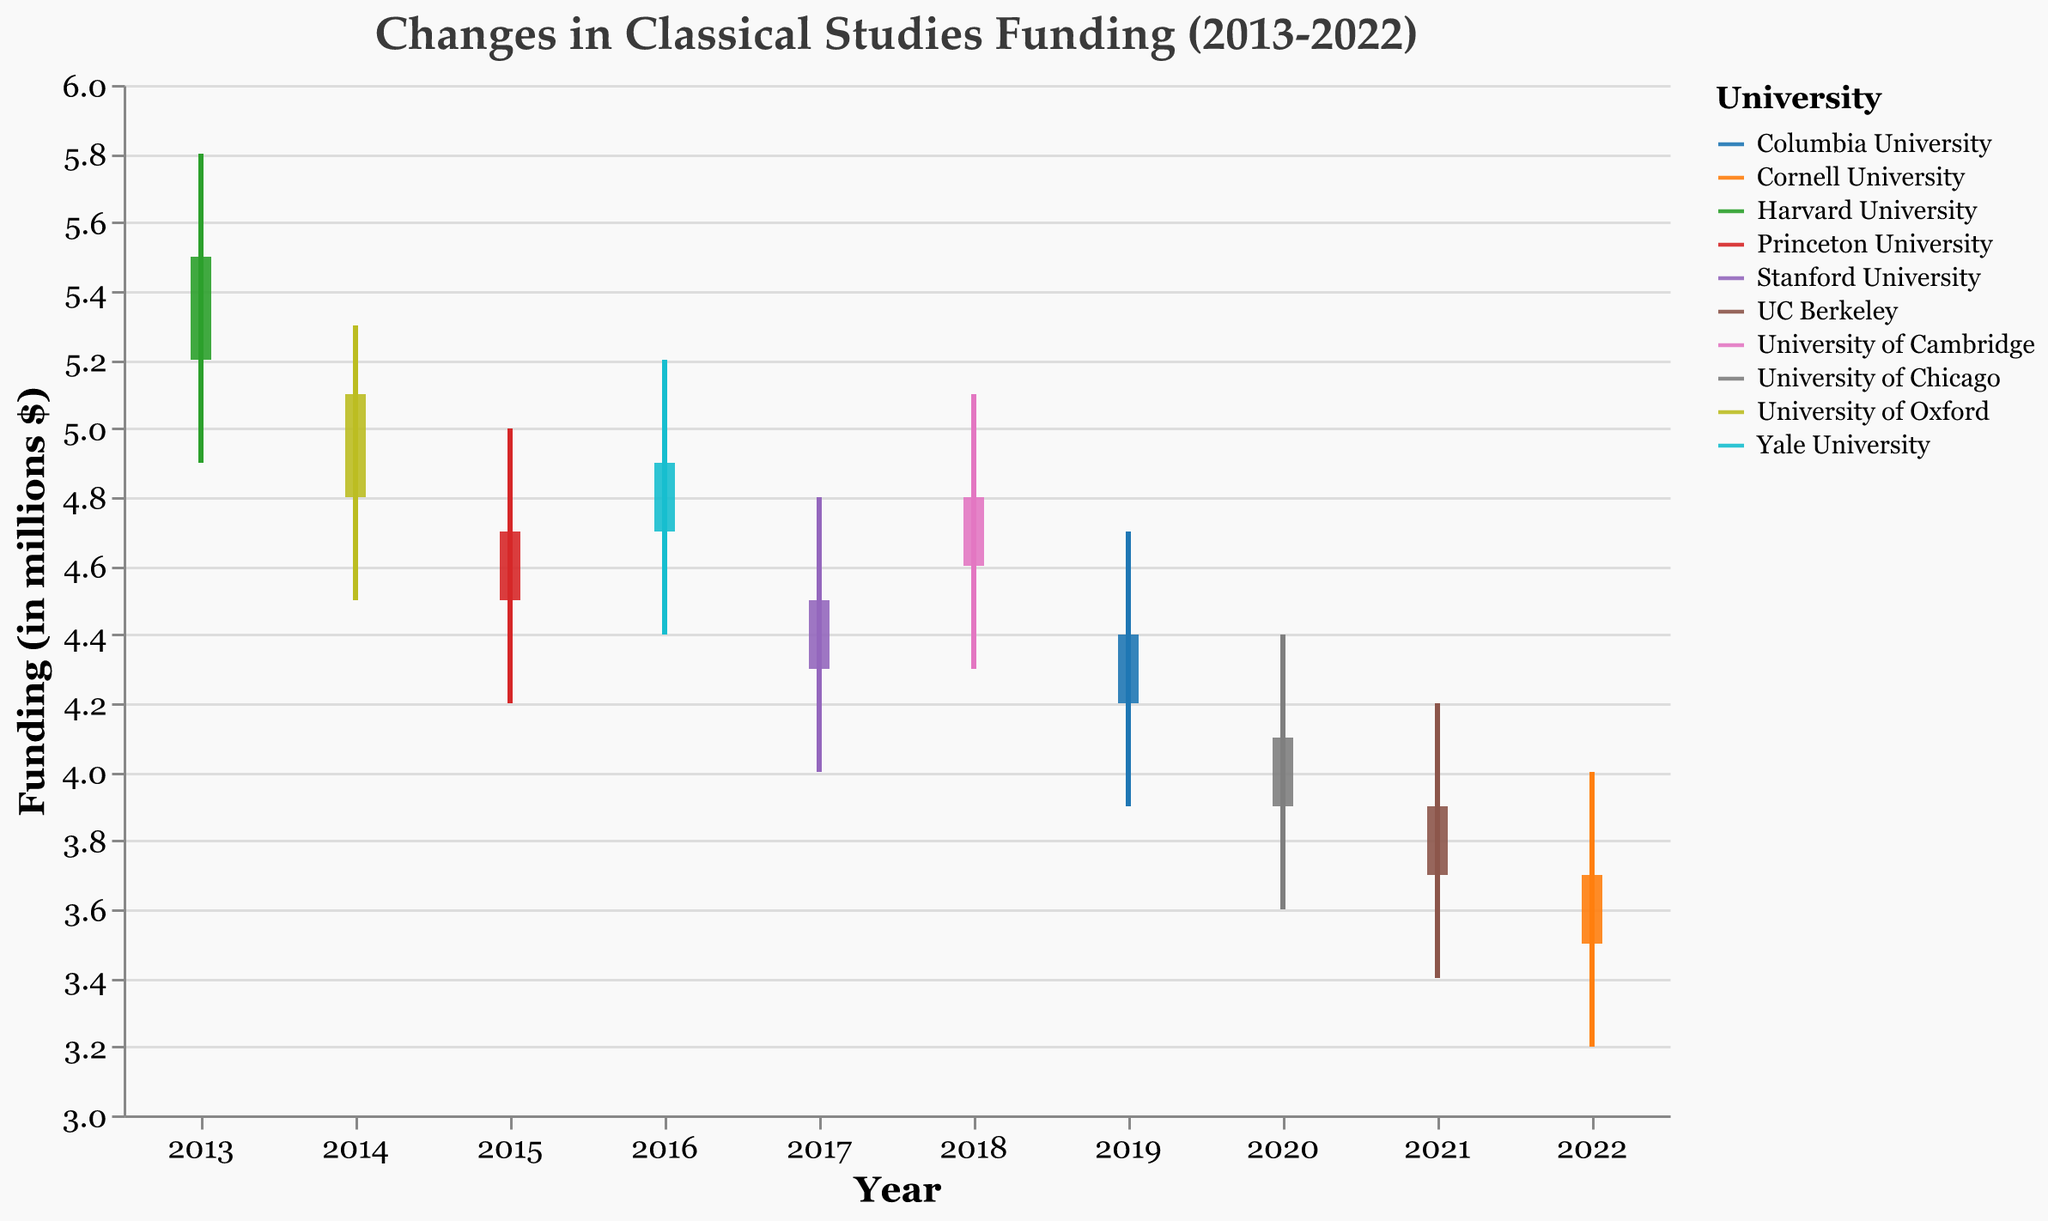What is the title of the chart? The title of the chart is prominently displayed at the top and reads "Changes in Classical Studies Funding (2013-2022)."
Answer: Changes in Classical Studies Funding (2013-2022) Which year had the highest funding value for Harvard University? Looking at the OHLC bars, the highest funding value for Harvard University is depicted by the high mark on the rule for the year 2013, reading $5.8 million.
Answer: 2013 Compare the funding trend for Stanford University and Princeton University over the years shown. Who experienced the larger drop from their initial 'Open' value to their final 'Close' value? Stanford University's funding opened at $4.3 million and closed at $4.5 million in 2017, dropping by -0.2 million. Princeton University opened at $4.5 million and closed at $4.7 million in 2015, dropping by -0.2 million. Hence, both universities experienced an equal drop in funding.
Answer: Equal drop What is the median of the 'High' values across all recorded years? To find the median, first arrange the high values in ascending order: 4.0, 4.2, 4.4, 4.7, 4.8, 5.0, 5.1, 5.2, 5.3, 5.8. Since there are 10 values, the median will be the average of the 5th and 6th values: (4.8 + 5.0) / 2 = 4.9.
Answer: 4.9 Which university showed a decreasing trend in funding from opening to closing consistently over the years? By examining the close value of each university, University of Cambridge, Columbia University, University of Chicago, UC Berkeley, and Cornell University each had a consistent decrease from open to close.
Answer: Multiple universities Identify the university with the lowest funding in 2022. The lowest funding is shown by the low mark on the rule for 2022. Viewing the low value for Cornell University in 2022 shows it is $3.2 million.
Answer: Cornell University Which year recorded the smallest range between the 'Low' and 'High' funding values, and what was the range? The year with the smallest range can be found by finding the smallest difference between each 'Low' and 'High' value. For 2017 (Stanford University), the difference is 4.8 - 4.0 = 0.8 million, which is the smallest.
Answer: 2017, 0.8 million Were there any universities that saw an increase in funding, from their 'Low' value to their 'High' value, yet ended with a funding lower than what they started? From 2014 - University of Oxford (4.5 low and 5.3 high, closed 5.1); 2018 - University of Cambridge (4.3 low and 5.1 high, closed 4.8), and a few others saw increases in between values but closed lower than their open.
Answer: Yes, e.g., Oxford 2014 & Cambridge 2018 